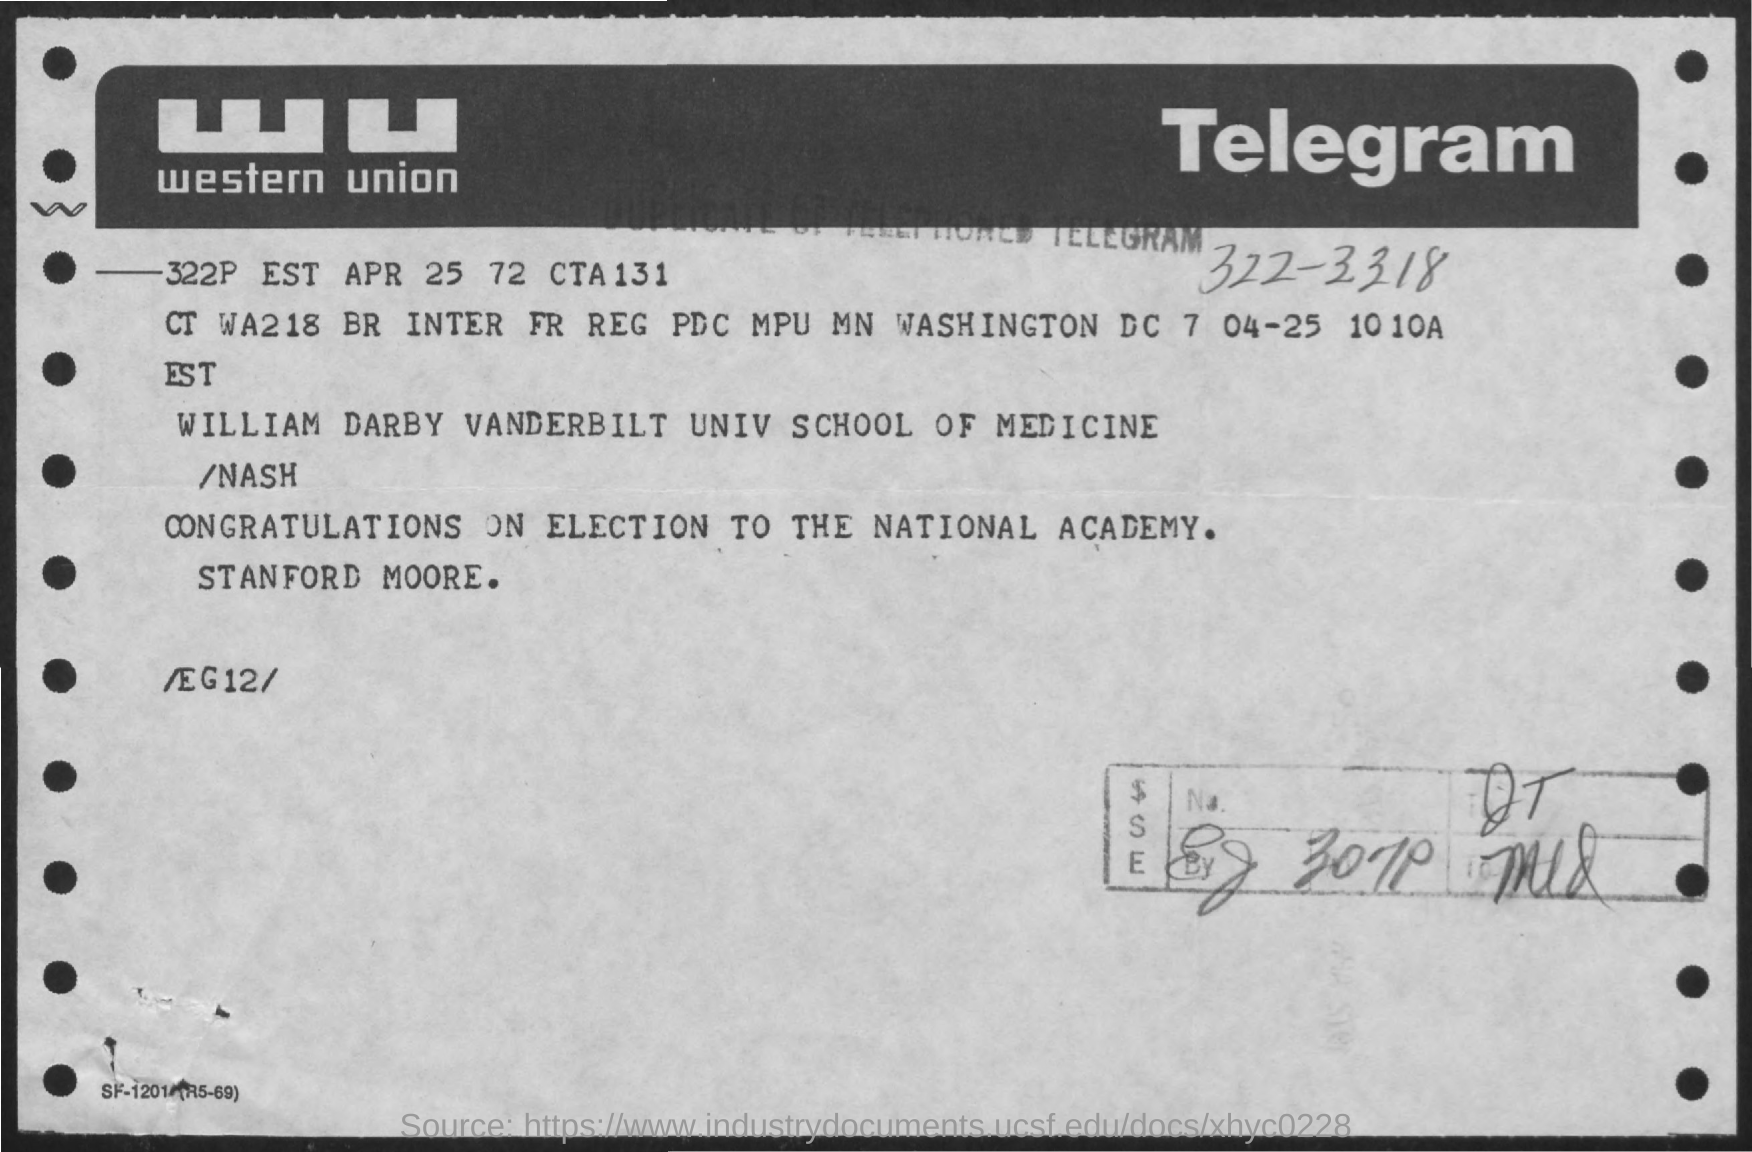What kind of communication is this?
Keep it short and to the point. Telegram. What was the telegram message ?
Keep it short and to the point. CONGRATULATIONS ON ELECTION TO THE NATIONAL ACADEMY. 